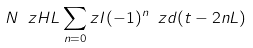Convert formula to latex. <formula><loc_0><loc_0><loc_500><loc_500>N \ z H L \sum _ { n = 0 } ^ { \ } z I ( - 1 ) ^ { n } \ z d ( t - 2 n L )</formula> 